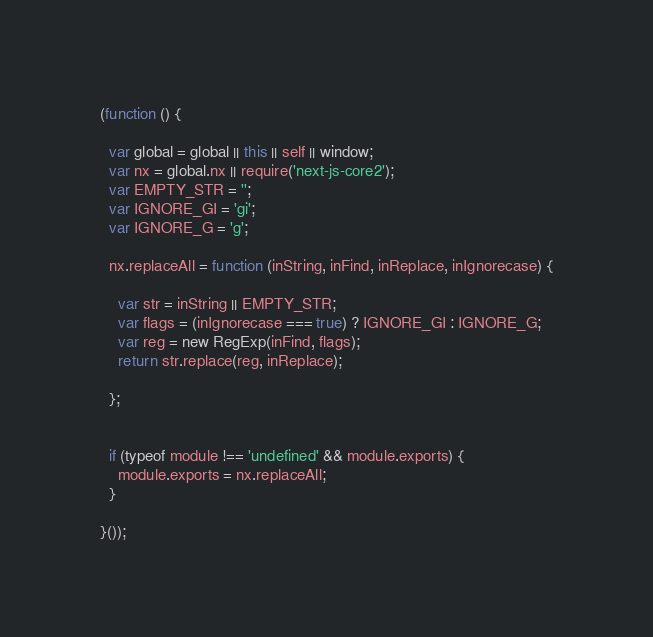Convert code to text. <code><loc_0><loc_0><loc_500><loc_500><_JavaScript_>(function () {

  var global = global || this || self || window;
  var nx = global.nx || require('next-js-core2');
  var EMPTY_STR = '';
  var IGNORE_GI = 'gi';
  var IGNORE_G = 'g';

  nx.replaceAll = function (inString, inFind, inReplace, inIgnorecase) {

    var str = inString || EMPTY_STR;
    var flags = (inIgnorecase === true) ? IGNORE_GI : IGNORE_G;
    var reg = new RegExp(inFind, flags);
    return str.replace(reg, inReplace);

  };


  if (typeof module !== 'undefined' && module.exports) {
    module.exports = nx.replaceAll;
  }

}());
</code> 